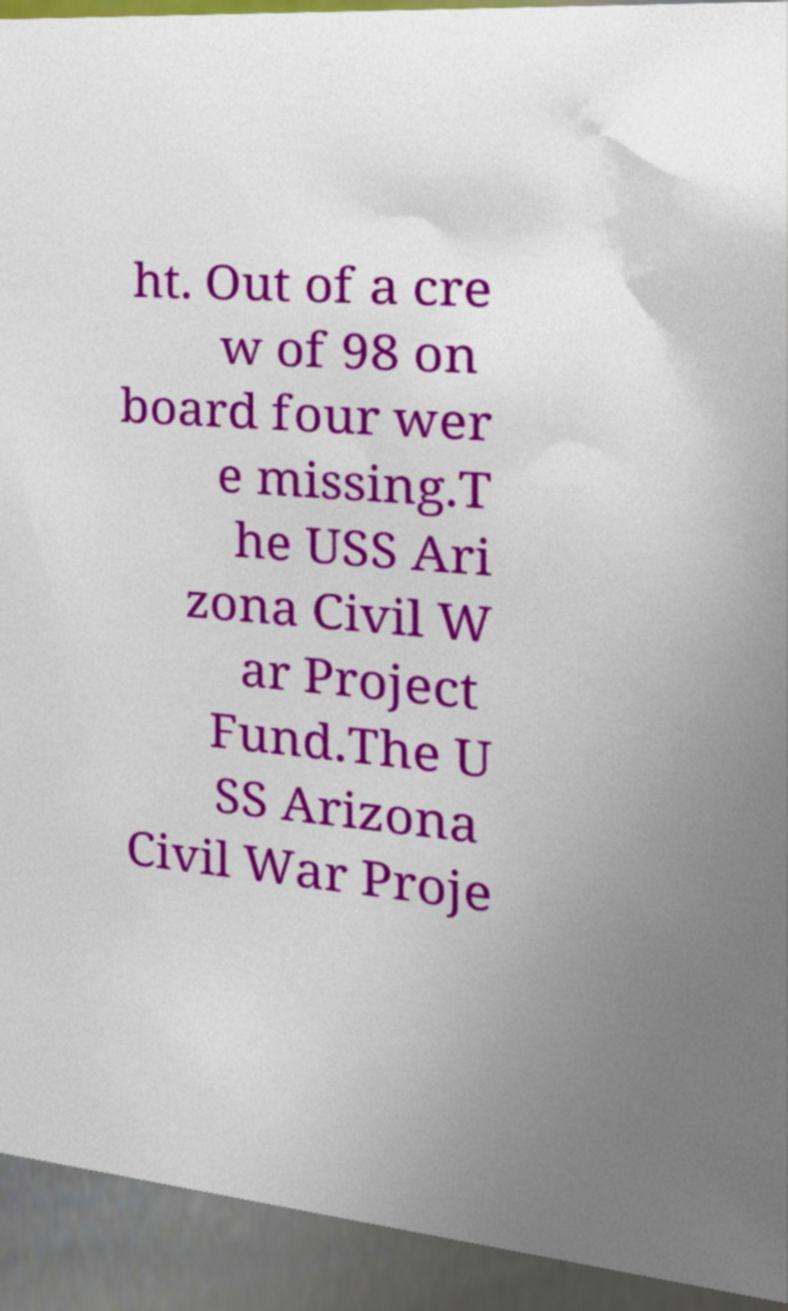What messages or text are displayed in this image? I need them in a readable, typed format. ht. Out of a cre w of 98 on board four wer e missing.T he USS Ari zona Civil W ar Project Fund.The U SS Arizona Civil War Proje 